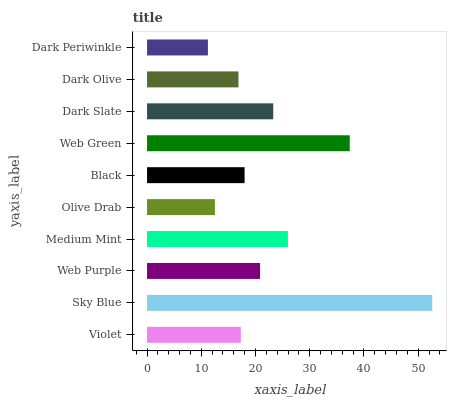Is Dark Periwinkle the minimum?
Answer yes or no. Yes. Is Sky Blue the maximum?
Answer yes or no. Yes. Is Web Purple the minimum?
Answer yes or no. No. Is Web Purple the maximum?
Answer yes or no. No. Is Sky Blue greater than Web Purple?
Answer yes or no. Yes. Is Web Purple less than Sky Blue?
Answer yes or no. Yes. Is Web Purple greater than Sky Blue?
Answer yes or no. No. Is Sky Blue less than Web Purple?
Answer yes or no. No. Is Web Purple the high median?
Answer yes or no. Yes. Is Black the low median?
Answer yes or no. Yes. Is Black the high median?
Answer yes or no. No. Is Dark Olive the low median?
Answer yes or no. No. 